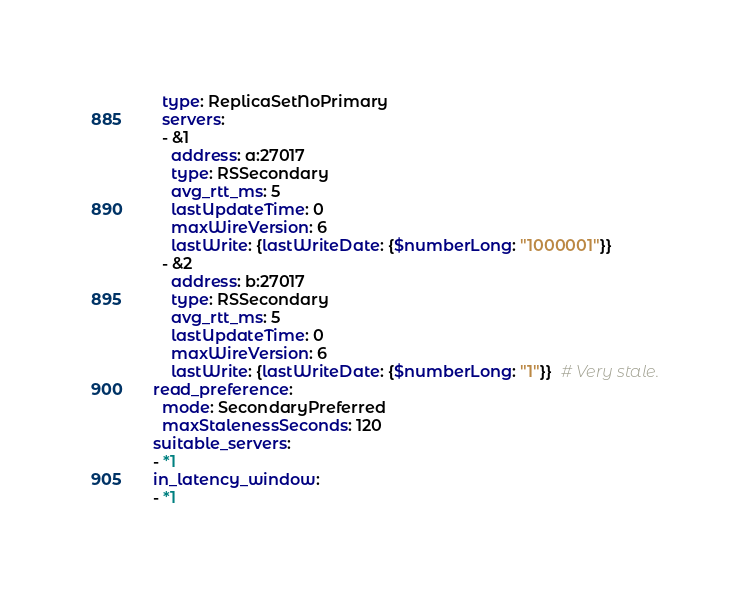Convert code to text. <code><loc_0><loc_0><loc_500><loc_500><_YAML_>  type: ReplicaSetNoPrimary
  servers:
  - &1
    address: a:27017
    type: RSSecondary
    avg_rtt_ms: 5
    lastUpdateTime: 0
    maxWireVersion: 6
    lastWrite: {lastWriteDate: {$numberLong: "1000001"}}
  - &2
    address: b:27017
    type: RSSecondary
    avg_rtt_ms: 5
    lastUpdateTime: 0
    maxWireVersion: 6
    lastWrite: {lastWriteDate: {$numberLong: "1"}}  # Very stale.
read_preference:
  mode: SecondaryPreferred
  maxStalenessSeconds: 120
suitable_servers:
- *1
in_latency_window:
- *1
</code> 